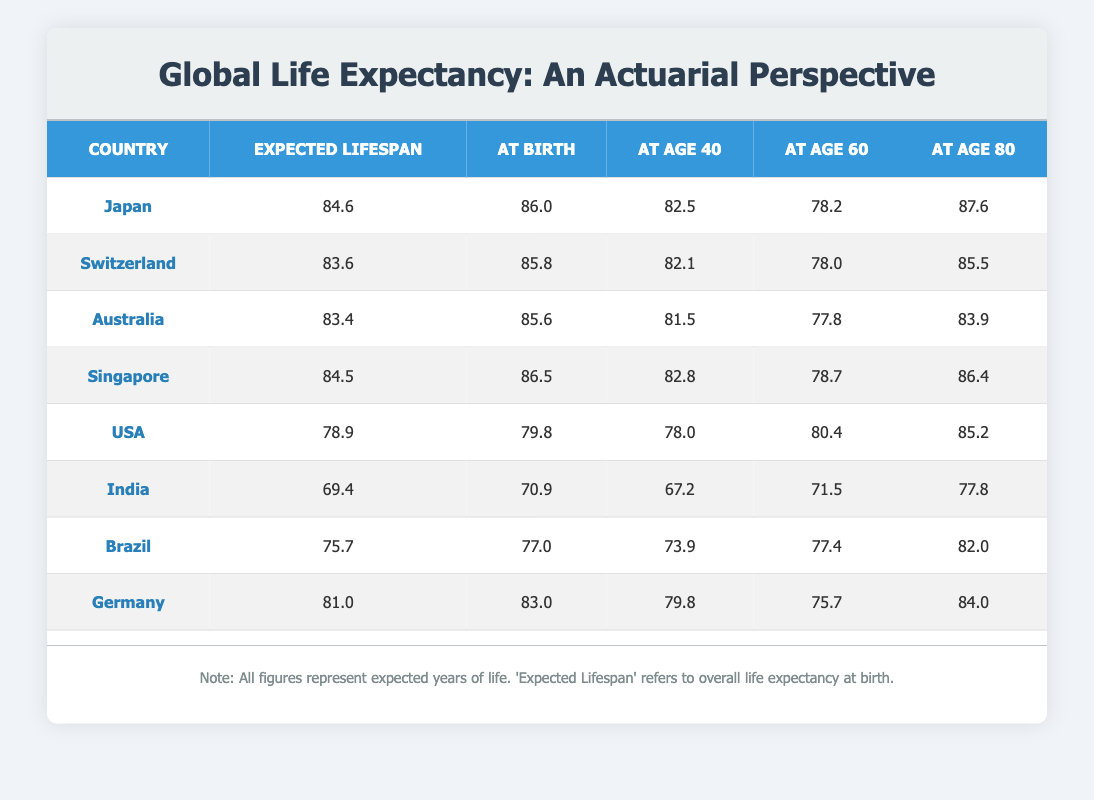What is the expected lifespan in Japan? The table lists the expected lifespan for various countries, and for Japan, the value is given directly as 84.6 years.
Answer: 84.6 Which country has the highest expected lifespan? By comparing the "Expected Lifespan" column across the countries, Japan has the highest expected lifespan at 84.6 years.
Answer: Japan What is the average expected lifespan of the countries listed? To find the average expected lifespan, we add the expected lifespans together: 84.6 + 83.6 + 83.4 + 84.5 + 78.9 + 69.4 + 75.7 + 81.0 =  641.1. Then we divide by the number of countries (8): 641.1 / 8 = 80.14.
Answer: 80.14 Is the expected lifespan in India greater than that in Brazil? The expected lifespan in India is 69.4 years and in Brazil is 75.7 years. Since 69.4 is less than 75.7, the statement is false.
Answer: No What is the difference in expected lifespan between the USA and Germany? The expected lifespan in the USA is 78.9 years, while in Germany, it is 81.0 years. To find the difference, we subtract: 81.0 - 78.9 = 2.1 years.
Answer: 2.1 If a person in Japan is currently 60 years old, how many more years can they expect to live? The expected lifespan for a 60-year-old in Japan is given as 78.2 years. Therefore, the additional years expected are 78.2 - 60 = 18.2 years.
Answer: 18.2 Which country has the lowest expected lifespan? Reviewing the data, India has the lowest expected lifespan at 69.4 years compared to the other countries listed.
Answer: India What is the expected lifespan for someone aged 40 in Switzerland? According to the data for Switzerland, the expected lifespan at age 40 is 82.1 years, which is directly stated in the table.
Answer: 82.1 